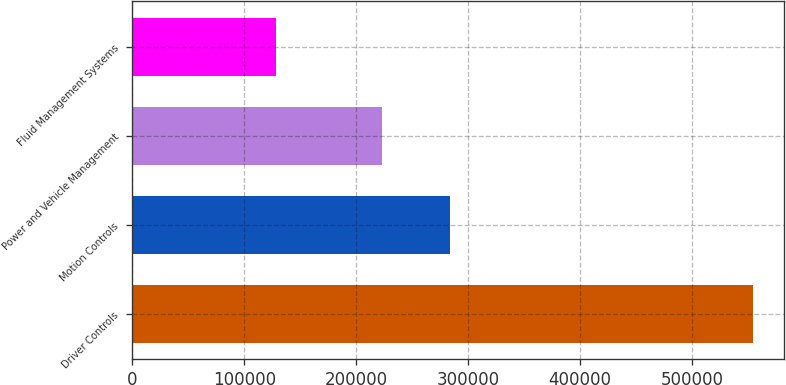<chart> <loc_0><loc_0><loc_500><loc_500><bar_chart><fcel>Driver Controls<fcel>Motion Controls<fcel>Power and Vehicle Management<fcel>Fluid Management Systems<nl><fcel>554707<fcel>283698<fcel>222951<fcel>128289<nl></chart> 